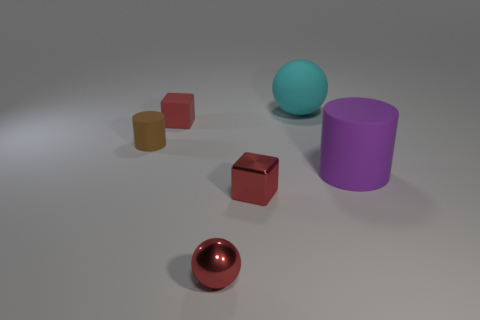Add 3 big yellow metallic objects. How many objects exist? 9 Subtract all blocks. How many objects are left? 4 Add 5 tiny blocks. How many tiny blocks are left? 7 Add 6 red objects. How many red objects exist? 9 Subtract 0 brown cubes. How many objects are left? 6 Subtract all red metal objects. Subtract all large cylinders. How many objects are left? 3 